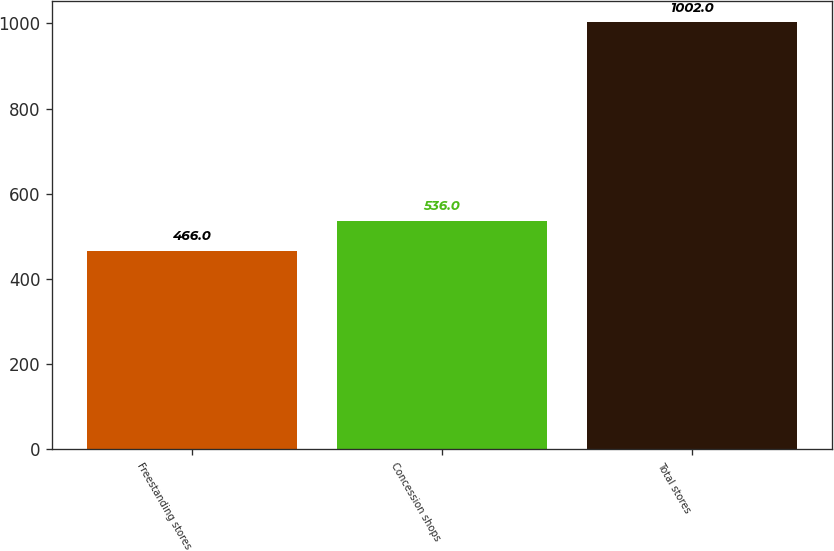Convert chart to OTSL. <chart><loc_0><loc_0><loc_500><loc_500><bar_chart><fcel>Freestanding stores<fcel>Concession shops<fcel>Total stores<nl><fcel>466<fcel>536<fcel>1002<nl></chart> 